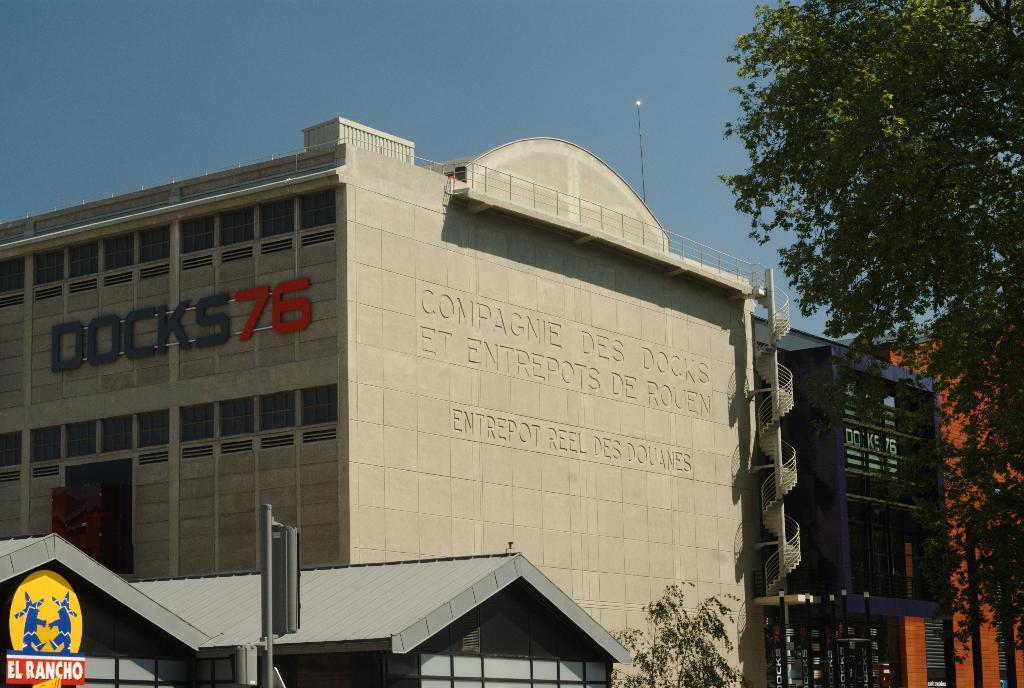Describe this image in one or two sentences. In this image, I can see the buildings with the windows. At the bottom and right sides of the image, I can see the trees. These are the name boards, which are attached to a building wall. At the bottom of the image, that looks like a pole. I can see the letters carved on a building wall. At the top of the image, I can see the sky. 